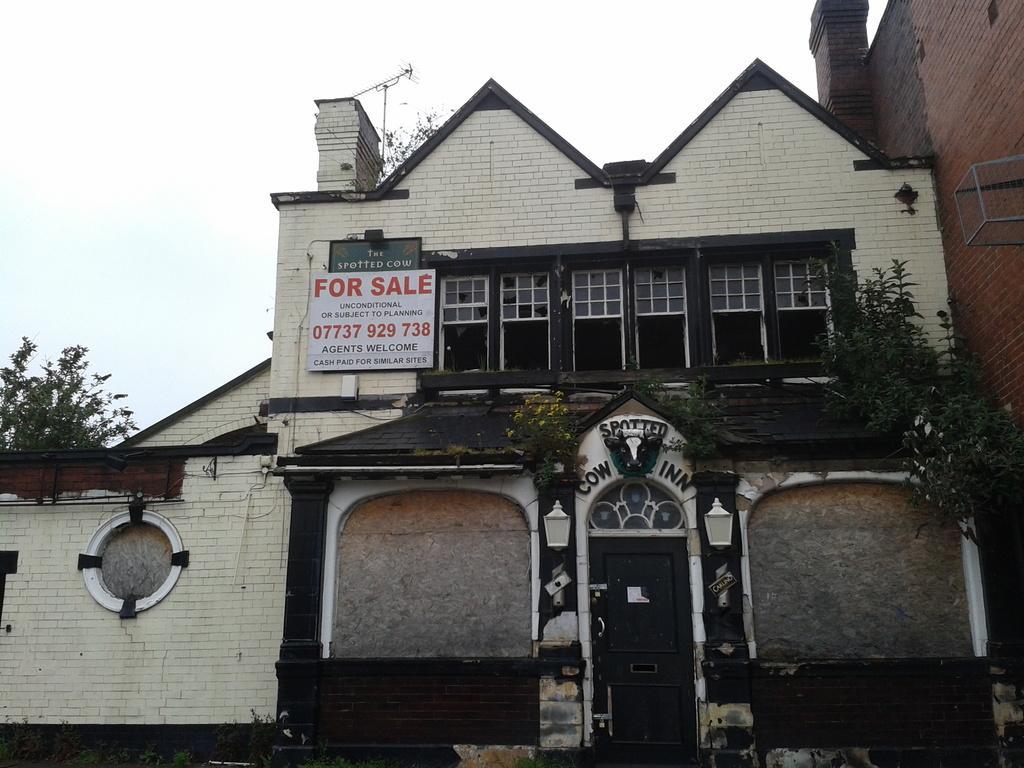Can you describe this image briefly? There is a building with windows and a door. On the building there are some plants and a board. On the board something is written. In the background there is sky. 